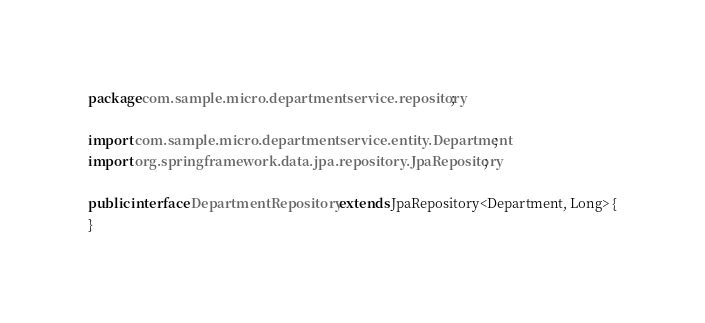<code> <loc_0><loc_0><loc_500><loc_500><_Java_>package com.sample.micro.departmentservice.repository;

import com.sample.micro.departmentservice.entity.Department;
import org.springframework.data.jpa.repository.JpaRepository;

public interface DepartmentRepository extends JpaRepository<Department, Long> {
}
</code> 